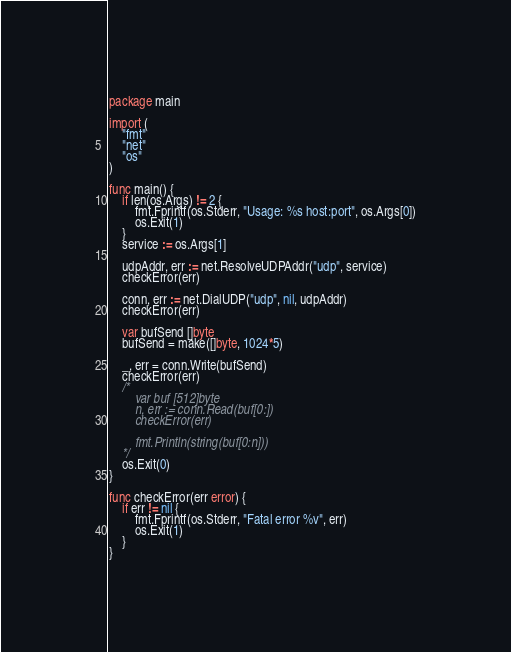<code> <loc_0><loc_0><loc_500><loc_500><_Go_>package main

import (
	"fmt"
	"net"
	"os"
)

func main() {
	if len(os.Args) != 2 {
		fmt.Fprintf(os.Stderr, "Usage: %s host:port", os.Args[0])
		os.Exit(1)
	}
	service := os.Args[1]

	udpAddr, err := net.ResolveUDPAddr("udp", service)
	checkError(err)

	conn, err := net.DialUDP("udp", nil, udpAddr)
	checkError(err)

	var bufSend []byte
	bufSend = make([]byte, 1024*5)

	_, err = conn.Write(bufSend)
	checkError(err)
	/*
		var buf [512]byte
		n, err := conn.Read(buf[0:])
		checkError(err)

		fmt.Println(string(buf[0:n]))
	*/
	os.Exit(0)
}

func checkError(err error) {
	if err != nil {
		fmt.Fprintf(os.Stderr, "Fatal error %v", err)
		os.Exit(1)
	}
}
</code> 